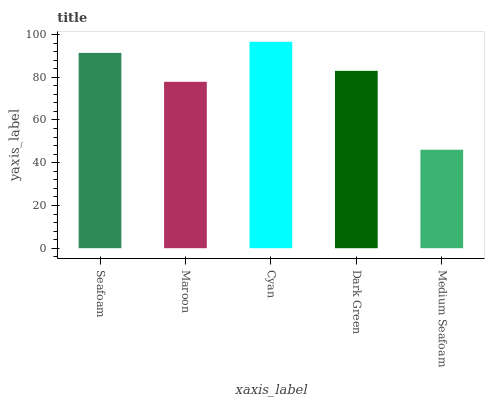Is Medium Seafoam the minimum?
Answer yes or no. Yes. Is Cyan the maximum?
Answer yes or no. Yes. Is Maroon the minimum?
Answer yes or no. No. Is Maroon the maximum?
Answer yes or no. No. Is Seafoam greater than Maroon?
Answer yes or no. Yes. Is Maroon less than Seafoam?
Answer yes or no. Yes. Is Maroon greater than Seafoam?
Answer yes or no. No. Is Seafoam less than Maroon?
Answer yes or no. No. Is Dark Green the high median?
Answer yes or no. Yes. Is Dark Green the low median?
Answer yes or no. Yes. Is Medium Seafoam the high median?
Answer yes or no. No. Is Seafoam the low median?
Answer yes or no. No. 